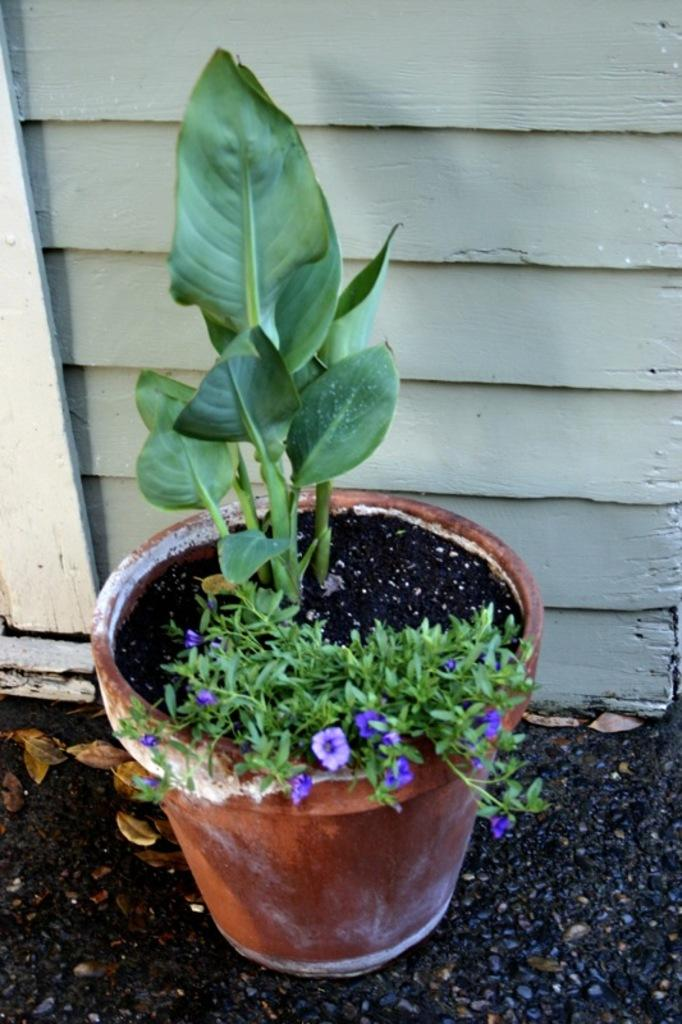What is the main object in the image? There is a pot in the image. What is inside the pot? The pot contains a plant. What is at the bottom of the pot? There is sand at the bottom of the pot. What type of material is the wall made of in the background? There is a wall made of wood in the background of the image. What type of sail can be seen in the image? There is no sail present in the image. What offer is being made by the plant in the pot? The plant in the pot is not making any offer; it is simply growing in the pot. 